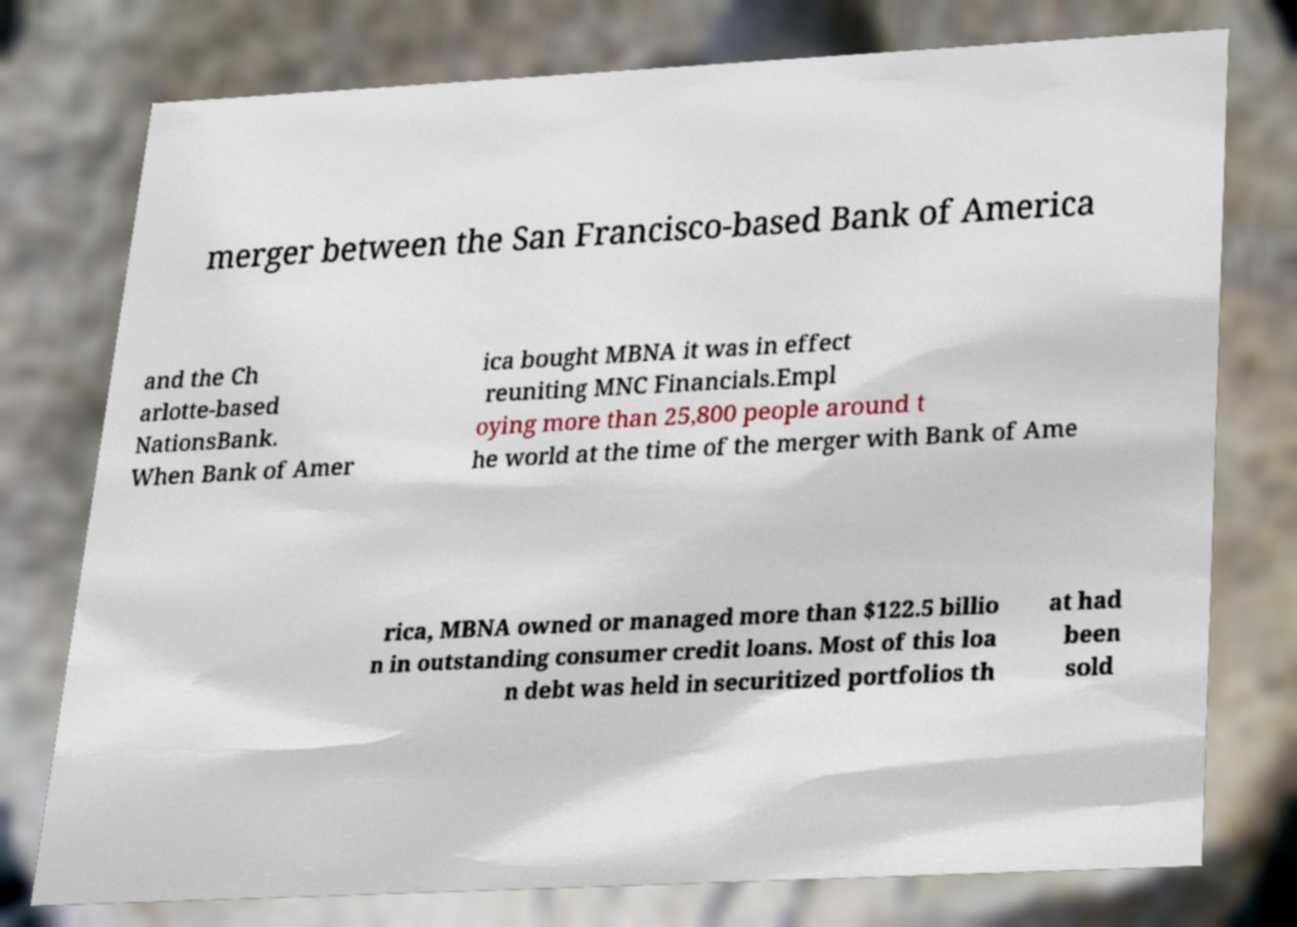I need the written content from this picture converted into text. Can you do that? merger between the San Francisco-based Bank of America and the Ch arlotte-based NationsBank. When Bank of Amer ica bought MBNA it was in effect reuniting MNC Financials.Empl oying more than 25,800 people around t he world at the time of the merger with Bank of Ame rica, MBNA owned or managed more than $122.5 billio n in outstanding consumer credit loans. Most of this loa n debt was held in securitized portfolios th at had been sold 